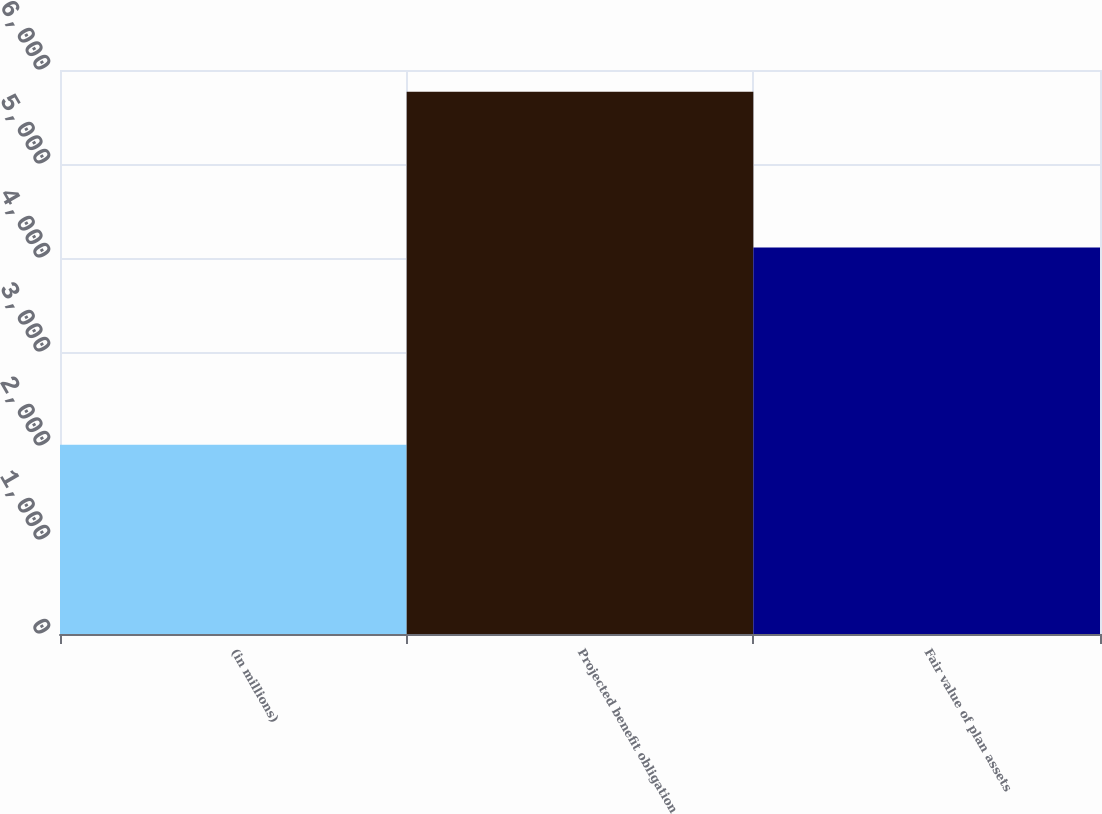Convert chart to OTSL. <chart><loc_0><loc_0><loc_500><loc_500><bar_chart><fcel>(in millions)<fcel>Projected benefit obligation<fcel>Fair value of plan assets<nl><fcel>2014<fcel>5769<fcel>4111<nl></chart> 